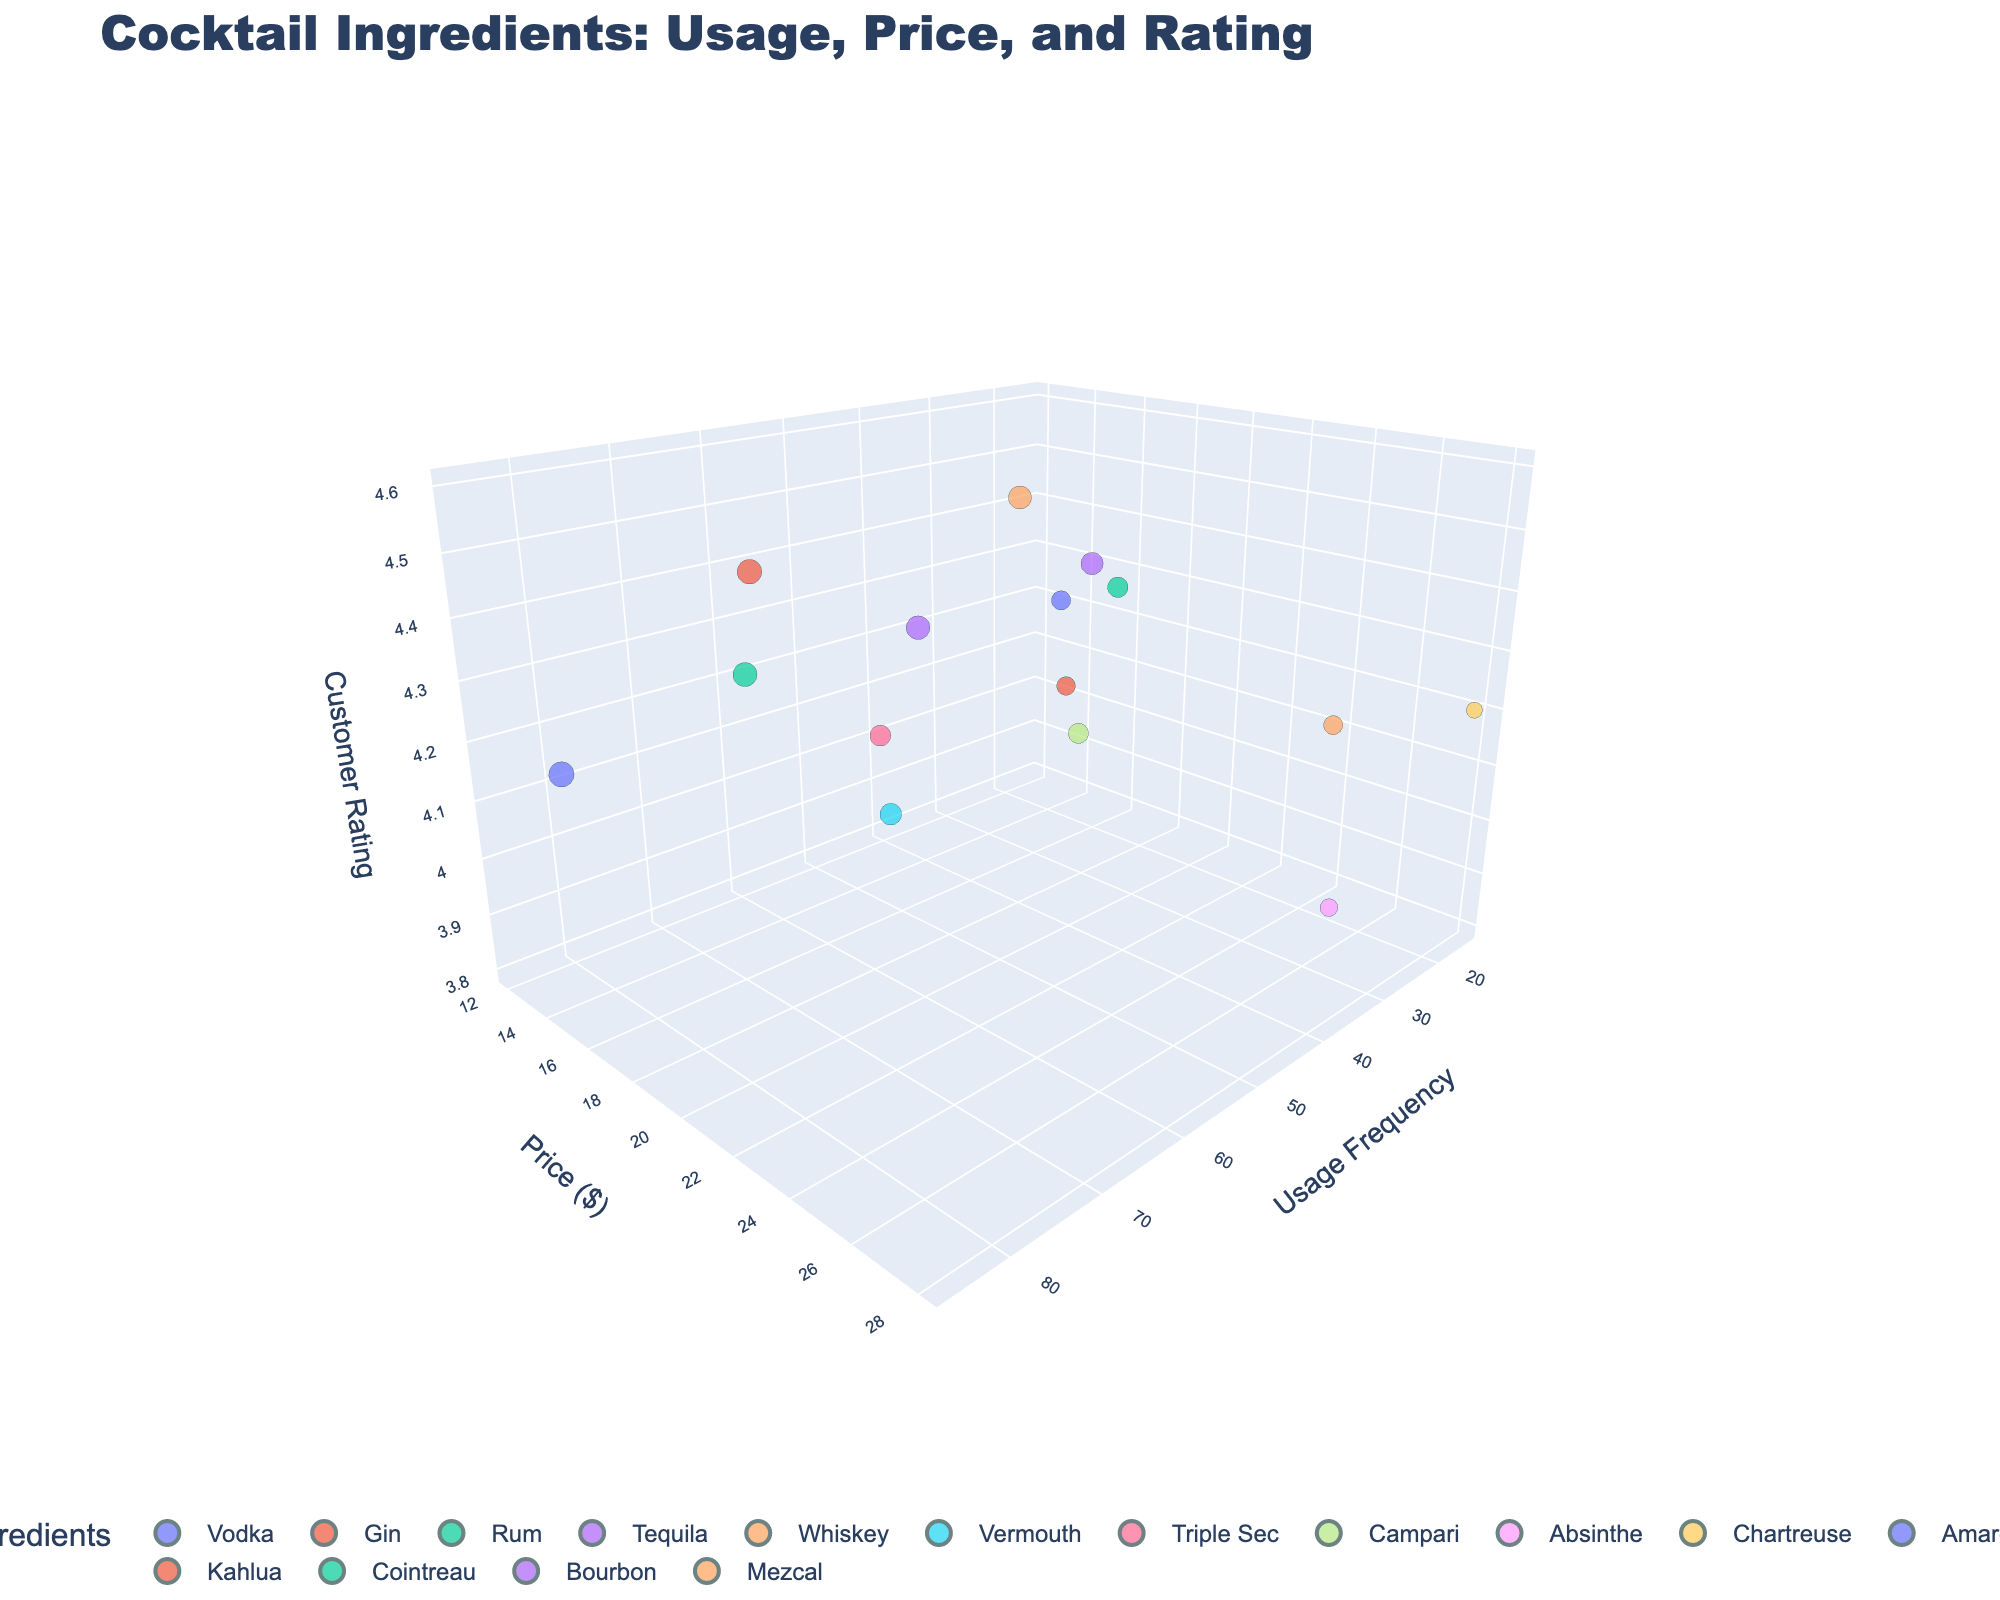What is the title of the chart? The title of the chart is displayed at the top of the figure. It reads "Cocktail Ingredients: Usage, Price, and Rating".
Answer: Cocktail Ingredients: Usage, Price, and Rating What are the three axes in the chart? The labels on the axes indicate their values. The x-axis represents Usage Frequency, the y-axis represents Price as "$", and the z-axis represents Customer Rating.
Answer: Usage Frequency, Price ($), Customer Rating Which ingredient has the highest Customer Rating? By observing the highest value on the z-axis (Customer Rating), the ingredient with the highest rating reaches 4.6, which corresponds to Whiskey.
Answer: Whiskey Which ingredient has the highest Price? Comparing the data points on the y-axis (Price), the highest point is at 28, which corresponds to Chartreuse.
Answer: Chartreuse How many ingredients have a Customer Rating above 4.0? Look for all the data points above the z-axis value of 4.0. Those ingredients are Vodka, Gin, Rum, Tequila, Whiskey, Amaretto, and Bourbon.
Answer: 7 What is the average Usage Frequency of Vodka and Gin? Vodka's usage frequency is 85, and Gin's usage frequency is 72. Calculating the average: (85 + 72) / 2 = 78.5.
Answer: 78.5 Which ingredient has both low Usage Frequency and low Customer Rating? The ingredient with low values on the x-axis (Usage Frequency) and z-axis (Customer Rating) is Absinthe.
Answer: Absinthe Is there a correlation between the Price and Customer Rating? Look for patterns between the y-axis (Price) and z-axis (Customer Rating). The data points do not form a clear correlation, indicating no strong relationship.
Answer: No Which ingredient's bubble size is noticeably larger due to high Popularity? The bubble size is based on Popularity. Vodka, with a popularity of 75, has a noticeably larger bubble compared to others.
Answer: Vodka Which are the most expensive ingredients with a Customer Rating above 4.0? The expensive ingredients (high y-axis values) with a z-axis (Customer Rating) above 4.0 are Tequila, Whiskey, Cointreau, and Bourbon.
Answer: Tequila, Whiskey, Cointreau, Bourbon 